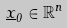Convert formula to latex. <formula><loc_0><loc_0><loc_500><loc_500>\underline { x } _ { 0 } \in \mathbb { R } ^ { n }</formula> 